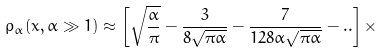<formula> <loc_0><loc_0><loc_500><loc_500>\rho _ { \alpha } ( x , \alpha \gg 1 ) \approx \left [ \sqrt { \frac { \alpha } { \pi } } - \frac { 3 } { 8 \sqrt { \pi \alpha } } - \frac { 7 } { 1 2 8 \alpha \sqrt { \pi \alpha } } - . . \right ] \times</formula> 